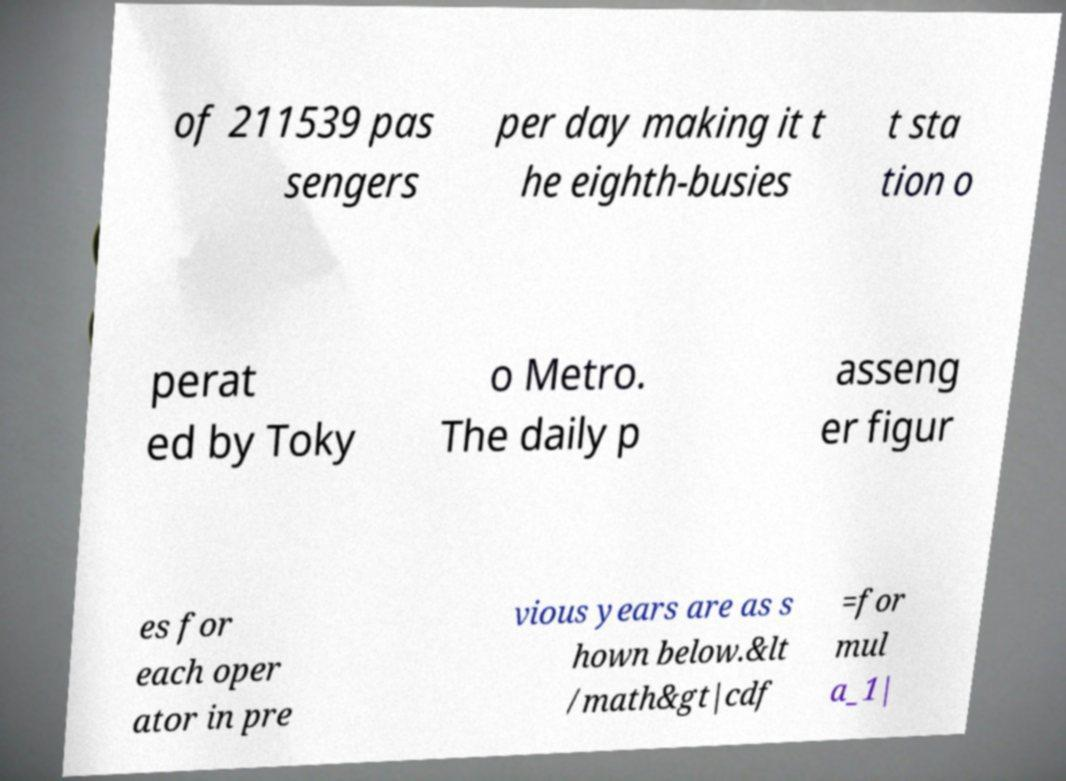There's text embedded in this image that I need extracted. Can you transcribe it verbatim? of 211539 pas sengers per day making it t he eighth-busies t sta tion o perat ed by Toky o Metro. The daily p asseng er figur es for each oper ator in pre vious years are as s hown below.&lt /math&gt|cdf =for mul a_1| 